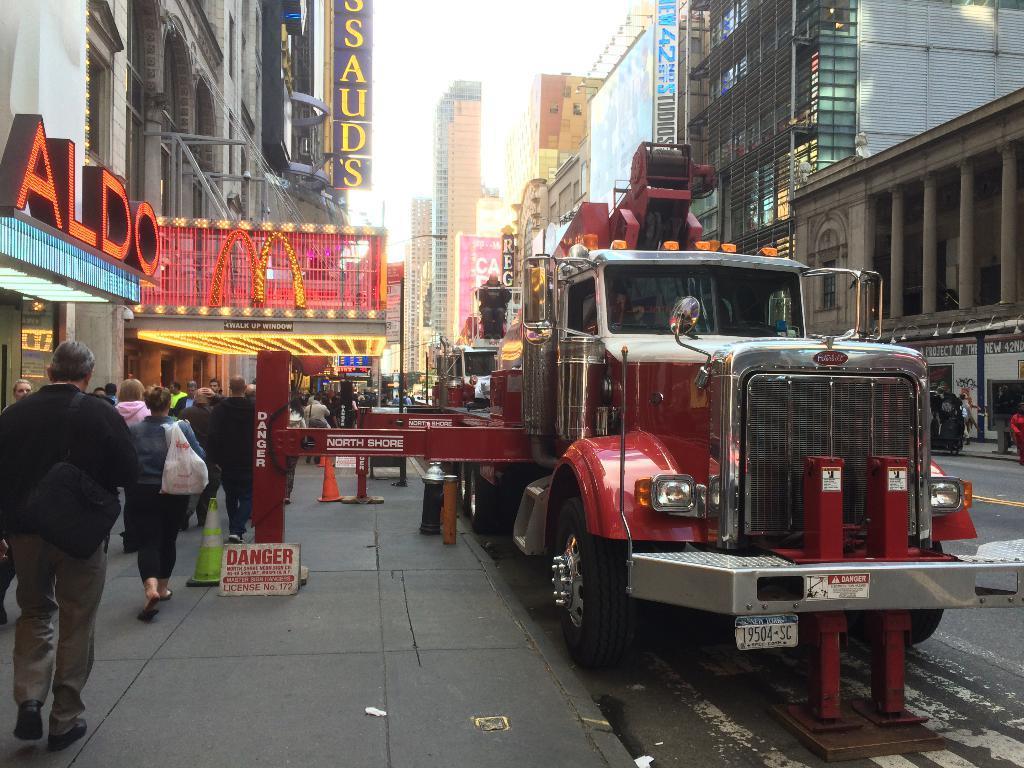In one or two sentences, can you explain what this image depicts? In this image on the left side there persons walking and there are boards, buildings and on the boards there is some text written on it. In the center there are vehicles and on the right side there are persons and there are buildings. In the background there are buildings with boards and on the board there is some text written on it. 